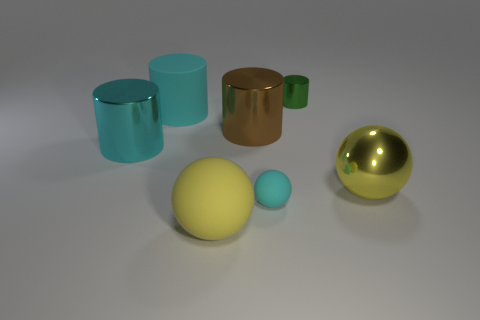Subtract all yellow cylinders. Subtract all yellow blocks. How many cylinders are left? 4 Subtract all brown blocks. How many yellow cylinders are left? 0 Add 4 small greens. How many small things exist? 0 Subtract all tiny cyan matte spheres. Subtract all blue cylinders. How many objects are left? 6 Add 7 tiny cylinders. How many tiny cylinders are left? 8 Add 4 tiny green blocks. How many tiny green blocks exist? 4 Add 2 blue rubber objects. How many objects exist? 9 Subtract all green cylinders. How many cylinders are left? 3 Subtract all large brown cylinders. How many cylinders are left? 3 Subtract 0 brown blocks. How many objects are left? 7 